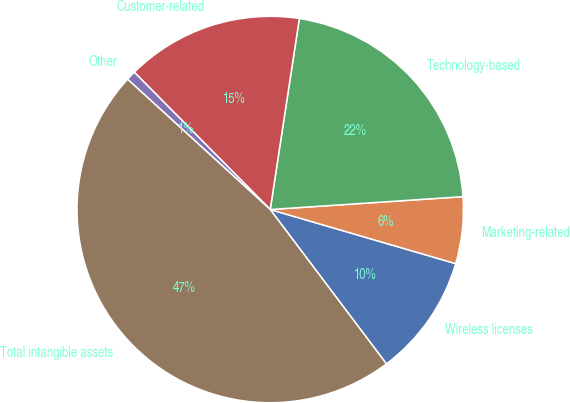Convert chart. <chart><loc_0><loc_0><loc_500><loc_500><pie_chart><fcel>Wireless licenses<fcel>Marketing-related<fcel>Technology-based<fcel>Customer-related<fcel>Other<fcel>Total intangible assets<nl><fcel>10.21%<fcel>5.58%<fcel>21.53%<fcel>14.83%<fcel>0.8%<fcel>47.05%<nl></chart> 